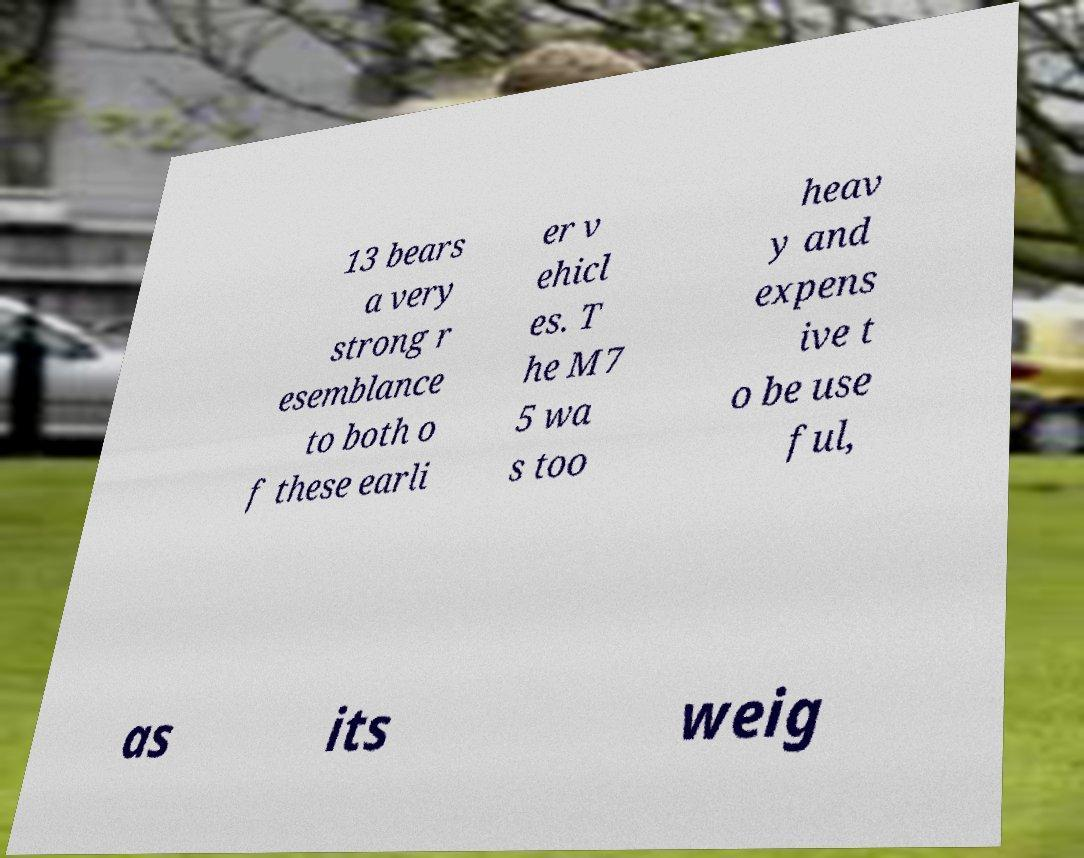Can you read and provide the text displayed in the image?This photo seems to have some interesting text. Can you extract and type it out for me? 13 bears a very strong r esemblance to both o f these earli er v ehicl es. T he M7 5 wa s too heav y and expens ive t o be use ful, as its weig 